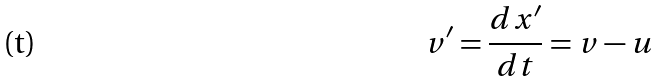Convert formula to latex. <formula><loc_0><loc_0><loc_500><loc_500>v ^ { \prime } = \frac { d x ^ { \prime } } { d t } = v - u</formula> 